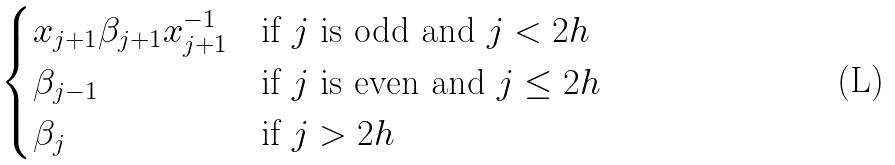Convert formula to latex. <formula><loc_0><loc_0><loc_500><loc_500>\begin{cases} x _ { j + 1 } \beta _ { j + 1 } x _ { j + 1 } ^ { - 1 } & \text {if $j$ is odd and $j<2h$} \\ \beta _ { j - 1 } & \text {if $j$ is even and $j\leq 2h$} \\ \beta _ { j } & \text {if $j> 2h$} \end{cases}</formula> 